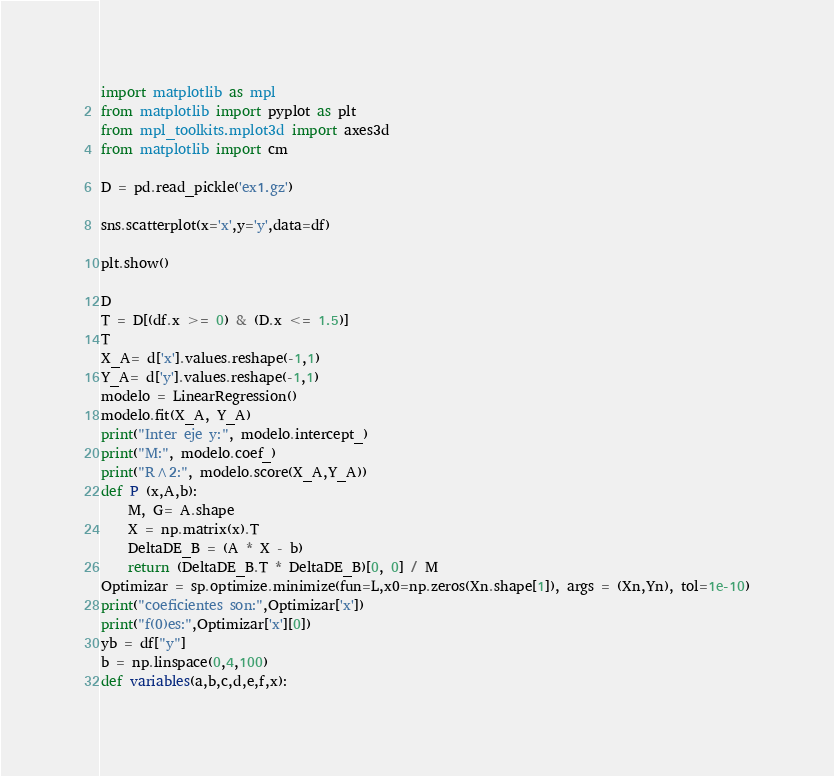Convert code to text. <code><loc_0><loc_0><loc_500><loc_500><_Python_>import matplotlib as mpl
from matplotlib import pyplot as plt
from mpl_toolkits.mplot3d import axes3d
from matplotlib import cm

D = pd.read_pickle('ex1.gz')

sns.scatterplot(x='x',y='y',data=df)

plt.show()

D
T = D[(df.x >= 0) & (D.x <= 1.5)]
T
X_A= d['x'].values.reshape(-1,1)
Y_A= d['y'].values.reshape(-1,1)
modelo = LinearRegression()
modelo.fit(X_A, Y_A)
print("Inter eje y:", modelo.intercept_)
print("M:", modelo.coef_)
print("R^2:", modelo.score(X_A,Y_A))
def P (x,A,b):
    M, G= A.shape
    X = np.matrix(x).T
    DeltaDE_B = (A * X - b)
    return (DeltaDE_B.T * DeltaDE_B)[0, 0] / M
Optimizar = sp.optimize.minimize(fun=L,x0=np.zeros(Xn.shape[1]), args = (Xn,Yn), tol=1e-10)
print("coeficientes son:",Optimizar['x'])
print("f(0)es:",Optimizar['x'][0])
yb = df["y"]
b = np.linspace(0,4,100)
def variables(a,b,c,d,e,f,x):</code> 